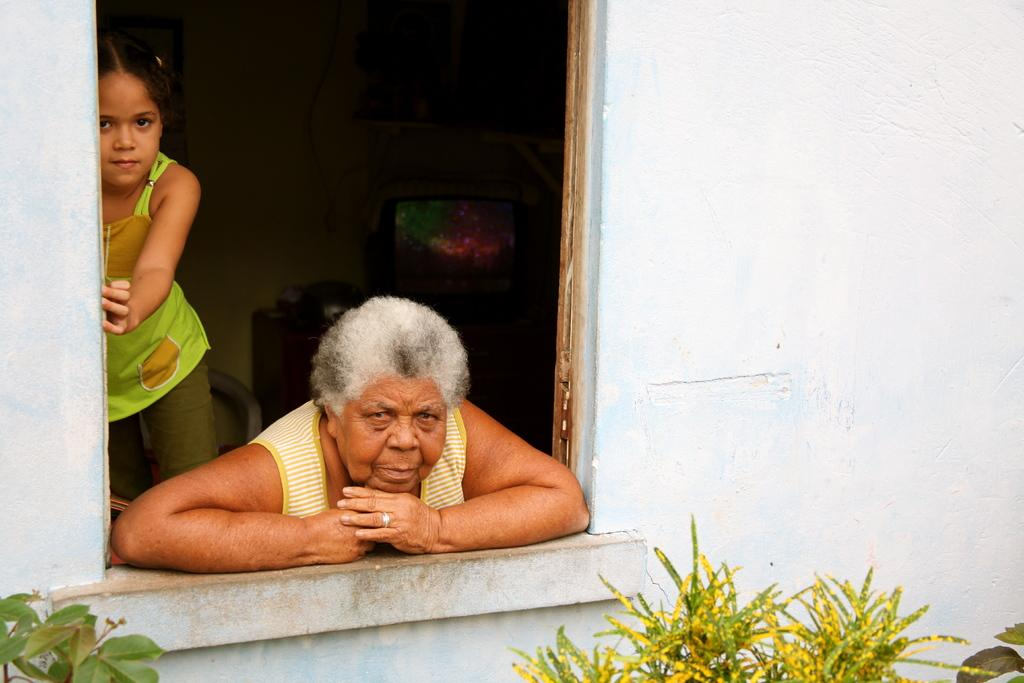Who is present in the image with the woman? There is a girl in the image with the woman. What are the woman and the girl doing in the image? They are standing at a window in the image. What can be seen at the bottom of the image? There are plants at the bottom of the image. What is visible on the sides of the image? There are walls on both the right and left sides of the image. What is the woman's partner doing in the image? There is no partner present in the image, as it only features the woman and the girl. 